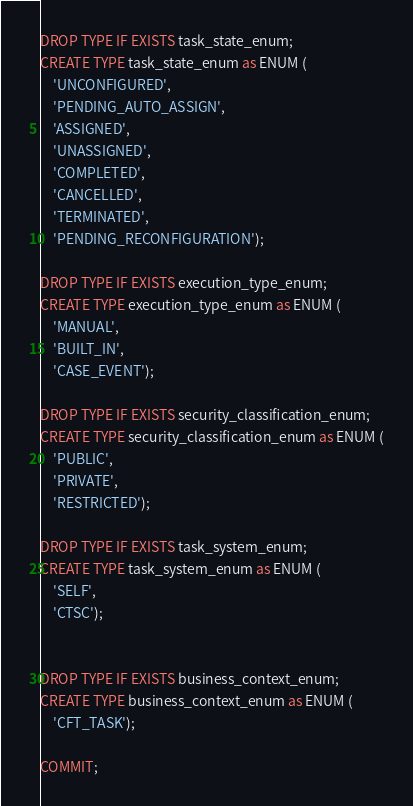Convert code to text. <code><loc_0><loc_0><loc_500><loc_500><_SQL_>DROP TYPE IF EXISTS task_state_enum;
CREATE TYPE task_state_enum as ENUM (
    'UNCONFIGURED',
    'PENDING_AUTO_ASSIGN',
    'ASSIGNED',
    'UNASSIGNED',
    'COMPLETED',
    'CANCELLED',
    'TERMINATED',
    'PENDING_RECONFIGURATION');

DROP TYPE IF EXISTS execution_type_enum;
CREATE TYPE execution_type_enum as ENUM (
    'MANUAL',
    'BUILT_IN',
    'CASE_EVENT');

DROP TYPE IF EXISTS security_classification_enum;
CREATE TYPE security_classification_enum as ENUM (
    'PUBLIC',
    'PRIVATE',
    'RESTRICTED');

DROP TYPE IF EXISTS task_system_enum;
CREATE TYPE task_system_enum as ENUM (
    'SELF',
    'CTSC');


DROP TYPE IF EXISTS business_context_enum;
CREATE TYPE business_context_enum as ENUM (
    'CFT_TASK');

COMMIT;
</code> 